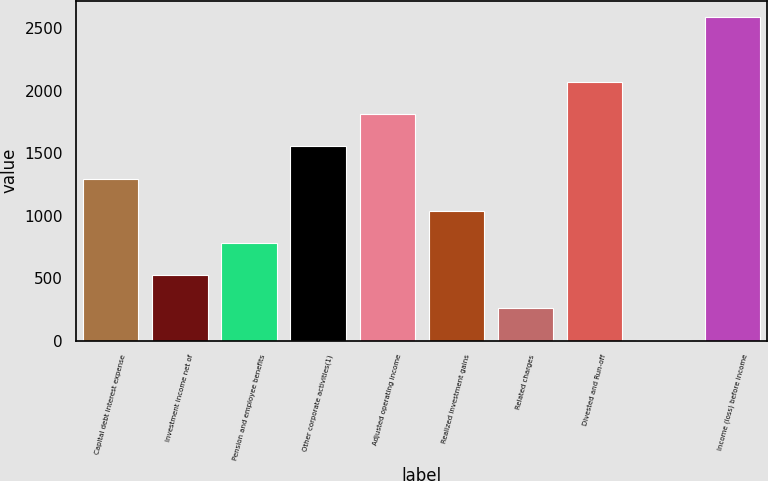Convert chart. <chart><loc_0><loc_0><loc_500><loc_500><bar_chart><fcel>Capital debt interest expense<fcel>Investment income net of<fcel>Pension and employee benefits<fcel>Other corporate activities(1)<fcel>Adjusted operating income<fcel>Realized investment gains<fcel>Related charges<fcel>Divested and Run-off<fcel>Unnamed: 8<fcel>Income (loss) before income<nl><fcel>1297.5<fcel>521.4<fcel>780.1<fcel>1556.2<fcel>1814.9<fcel>1038.8<fcel>262.7<fcel>2073.6<fcel>4<fcel>2591<nl></chart> 